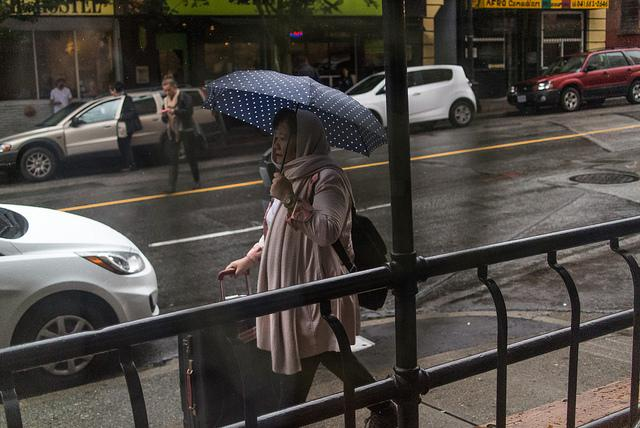Why is the woman carrying luggage? Please explain your reasoning. to travel. This wheeled single suitcase the woman is holding is suggestive of travel. 